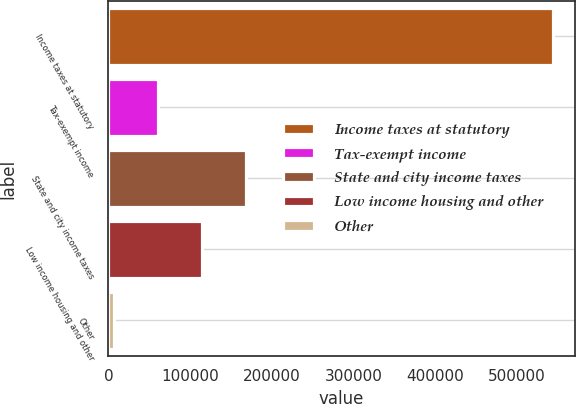Convert chart to OTSL. <chart><loc_0><loc_0><loc_500><loc_500><bar_chart><fcel>Income taxes at statutory<fcel>Tax-exempt income<fcel>State and city income taxes<fcel>Low income housing and other<fcel>Other<nl><fcel>543384<fcel>60827.4<fcel>168062<fcel>114445<fcel>7210<nl></chart> 